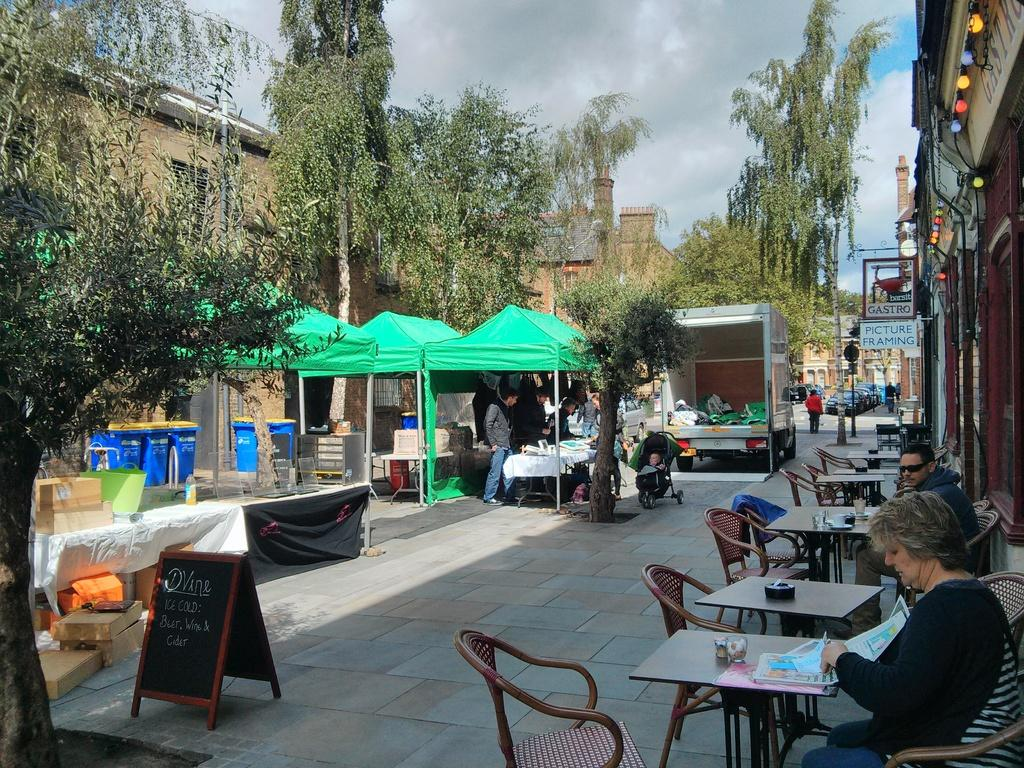What are the people in the image doing? The people in the image are sitting on chairs. What can be seen in the background of the image? There are many trees in the area. What structure is visible in the image? There is a tent in the image. What are the people inside the tent doing? People are standing inside the tent. What type of verse can be heard recited by the people in the image? There is no indication in the image that people are reciting any verses, so it cannot be determined from the picture. 